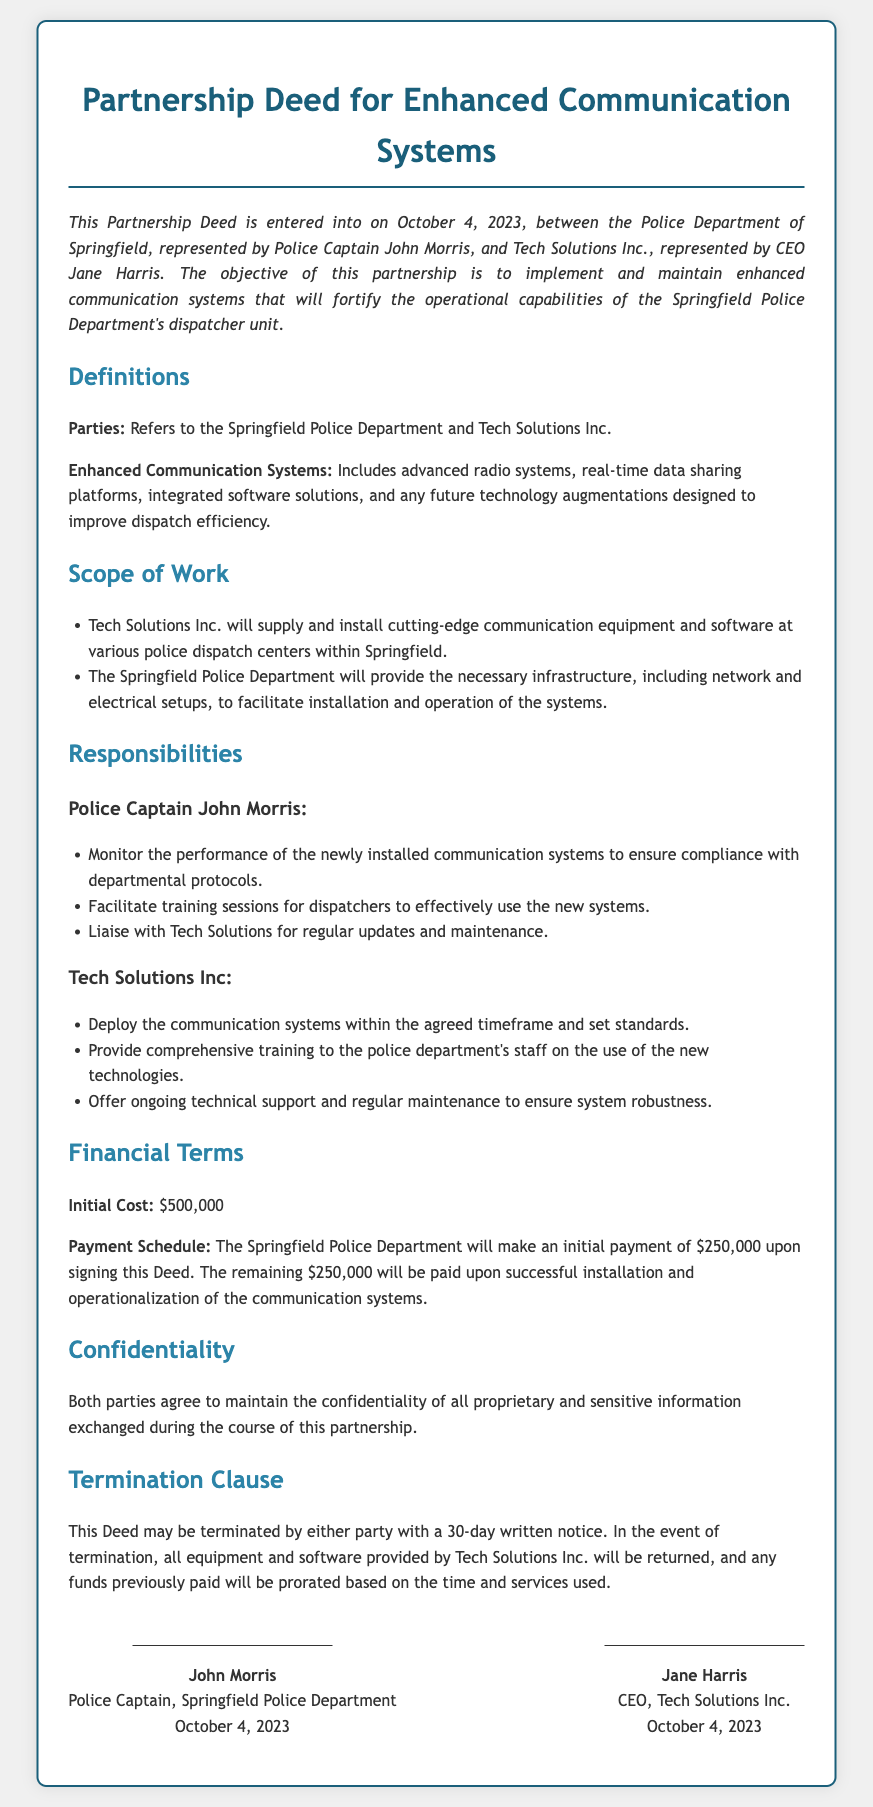What is the date this Deed was signed? The signing date of the Deed is explicitly mentioned in the introduction section of the document.
Answer: October 4, 2023 Who represents Tech Solutions Inc.? The document specifies the representative of Tech Solutions Inc. in the introduction.
Answer: Jane Harris What is the initial payment amount? The financial terms of the Deed detail the initial payment due upon signing.
Answer: $250,000 What is the total cost for the communication systems? The financial terms mention the total cost associated with the communication systems.
Answer: $500,000 What is the termination notice period? The termination clause specifies the amount of notice required for termination.
Answer: 30 days What is one duty of Police Captain John Morris? The responsibilities section outlines specific duties for Police Captain John Morris.
Answer: Monitor system performance What systems are included under Enhanced Communication Systems? The definition section outlines what is encompassed in the Enhanced Communication Systems.
Answer: Advanced radio systems What happens to equipment upon termination of the Deed? The termination clause elaborates on the required action regarding equipment if the Deed is terminated.
Answer: Returned What kind of support will Tech Solutions provide? The responsibilities section outlines the type of support Tech Solutions will provide to the police department.
Answer: Ongoing technical support 